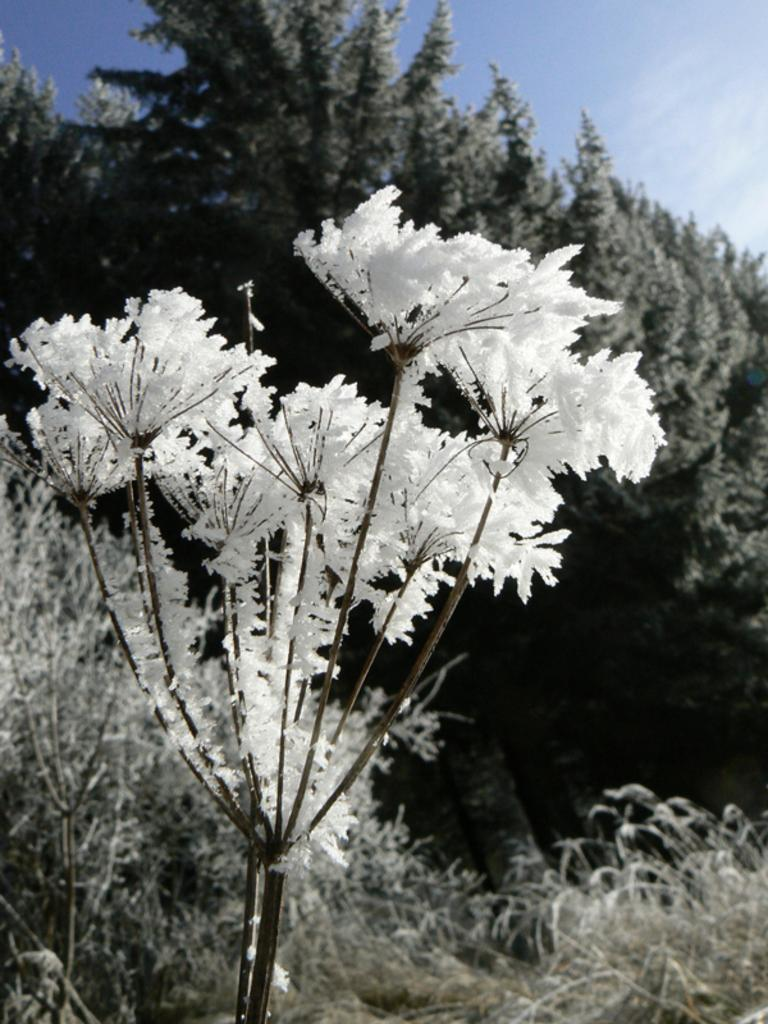What type of plant life is visible in the image? There are flowers with stems, plants with flowers, and trees visible in the image. Can you describe the flowers in the image? The flowers have stems in the image. What other types of plant life are present in the image? There are also plants with flowers and trees in the image. What type of club is being played by the guitarist in the image? There is no guitarist or club present in the image; it features flowers, plants, and trees. 